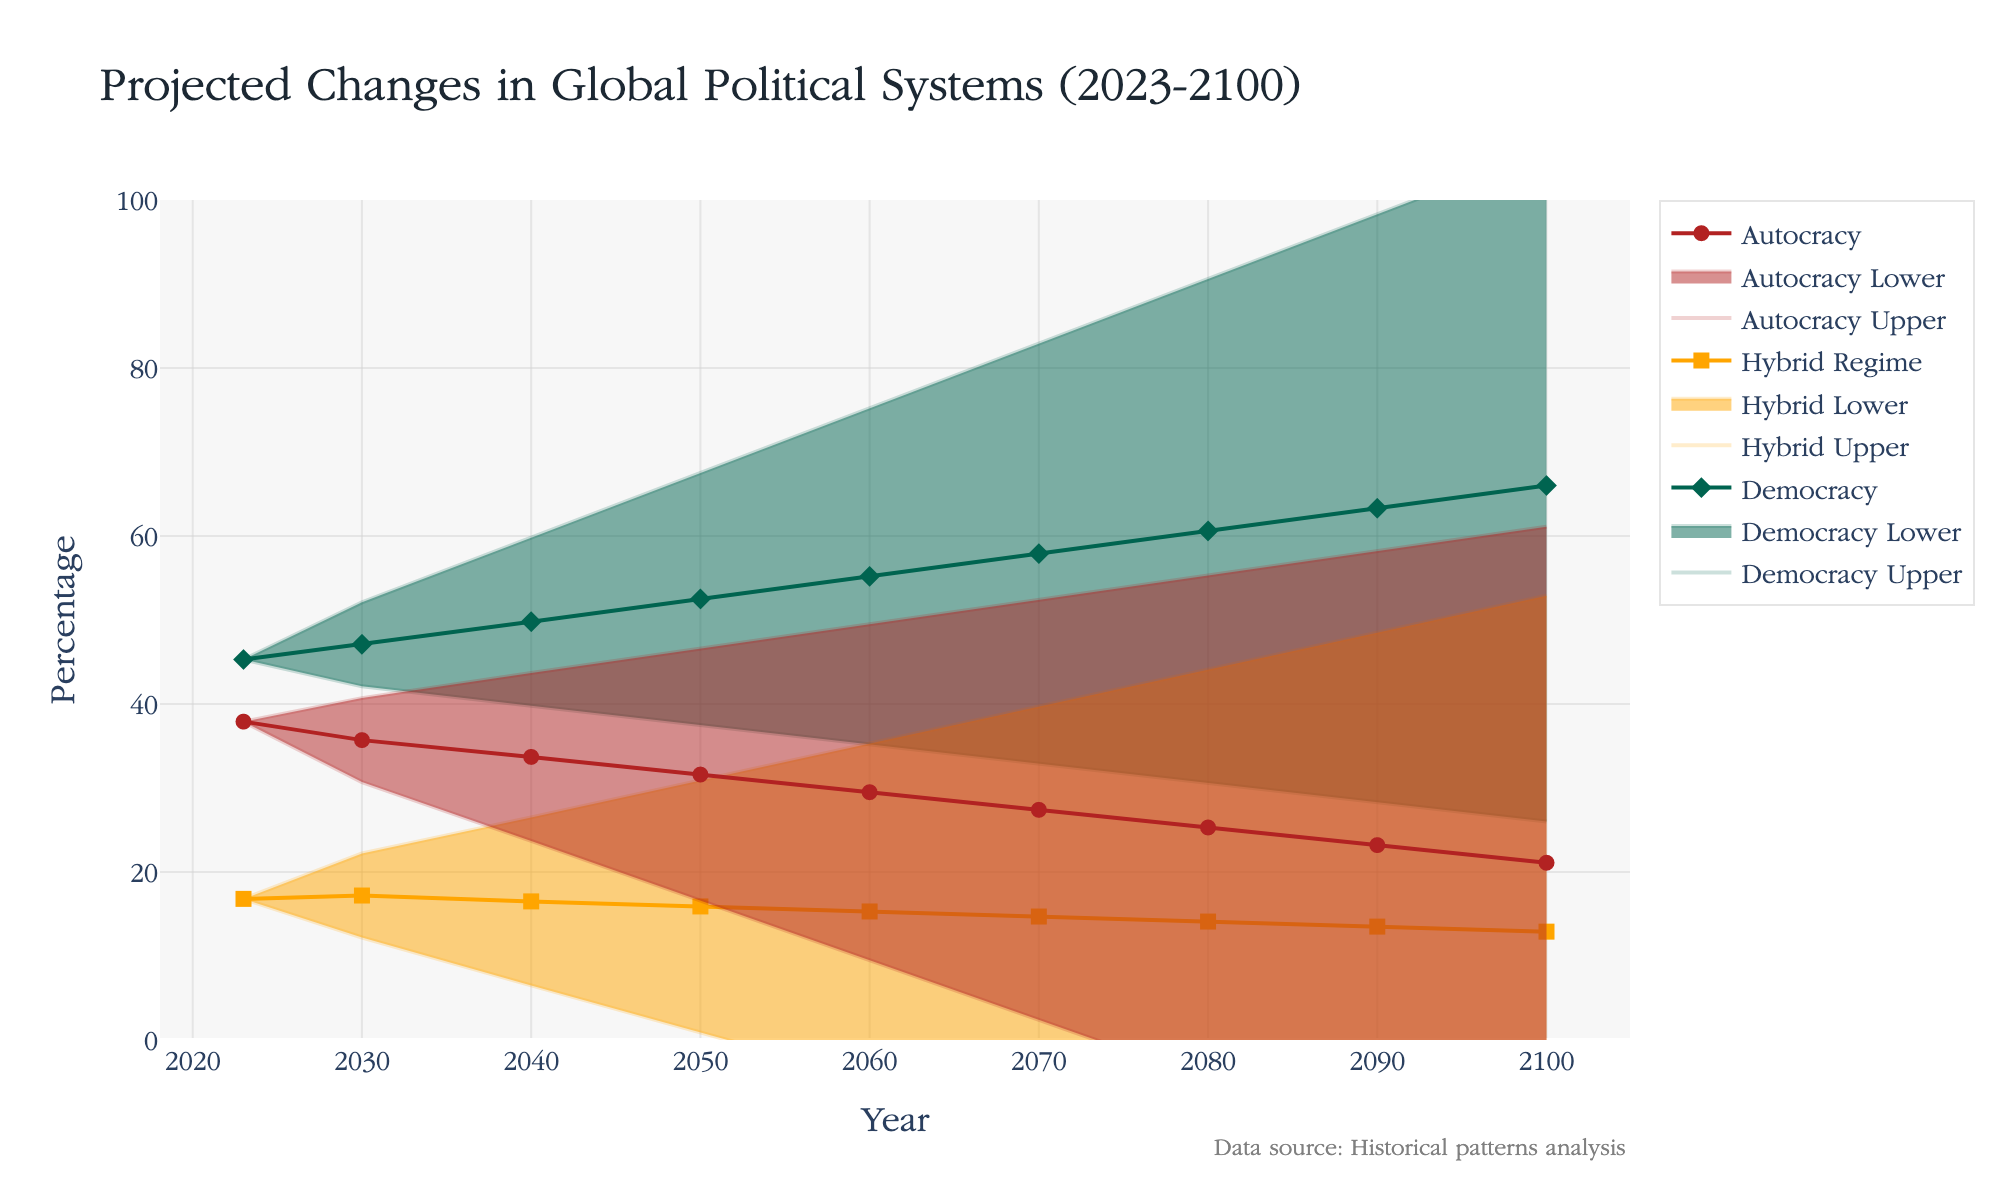What is the title of the figure? The title is typically at the top of the figure and provides a clear summary of what the figure represents. It states 'Projected Changes in Global Political Systems (2023-2100).'
Answer: Projected Changes in Global Political Systems (2023-2100) What does the uncertainty range for Democracy reach by the year 2100? The uncertainty range is shown as the shaded area around the lines representing each political system. For Democracy in 2100, the upper bound is at 66.0 + 40 = 106.0 and the lower bound is at 66.0 - 40 = 26.0.
Answer: 40 How does the percentage of Hybrid Regime systems in 2050 compare to that in 2100? To compare the percentages, we look at the values on the y-axis for Hybrid Regime at 2050 (15.9) and at 2100 (12.9). 15.9 is higher than 12.9.
Answer: Higher in 2050 Which political system is projected to have the largest increase in percentage from 2023 to 2100? By calculating the difference for each political system, Democracy increases from 45.3 to 66.0 (20.7), Hybrid Regime decreases from 16.8 to 12.9 (-3.9), and Autocracy decreases from 37.9 to 21.1 (-16.8). Democracy has the largest increase.
Answer: Democracy By what year is Democracy expected to surpass 50%? Looking at the trend line for Democracy, it first surpasses the 50% mark between 2040 (49.8) and 2050 (52.5).
Answer: 2050 What is the trend in the distribution of Autocracy percentage over the years? The trend line for Autocracy shows a continuous decrease from 37.9 in 2023 to 21.1 in 2100, indicating a downward trend.
Answer: Downward What is the projected change in the percentage of Hybrid Regime systems between 2023 and 2060? The percentage for Hybrid Regime starts at 16.8 in 2023 and is projected to be 15.3 by 2060. The change is 15.3 - 16.8 = -1.5.
Answer: -1.5 What is the percentage difference between Democracy and Autocracy in 2070? To find the difference, subtract the percentage of Autocracy (27.4) from the percentage of Democracy (57.9) in 2070. The difference is 57.9 - 27.4 = 30.5.
Answer: 30.5 When do the upper bounds of the projections for Autocracy and Democracy intersect? To determine the intersection, we observe the upper bounds for both lines. Democracy's upper bound surpasses Autocracy's upper bound between 2070 (Democracy: 82.9, Autocracy: 52.4).
Answer: After 2060 